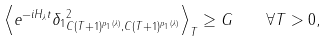<formula> <loc_0><loc_0><loc_500><loc_500>\left \langle \| e ^ { - i H _ { \lambda } t } \delta _ { 1 } \| _ { C ( T + 1 ) ^ { p _ { 1 } ( \lambda ) } , C ( T + 1 ) ^ { p _ { 1 } ( \lambda ) } } ^ { 2 } \right \rangle _ { T } \geq G \quad \forall T > 0 ,</formula> 